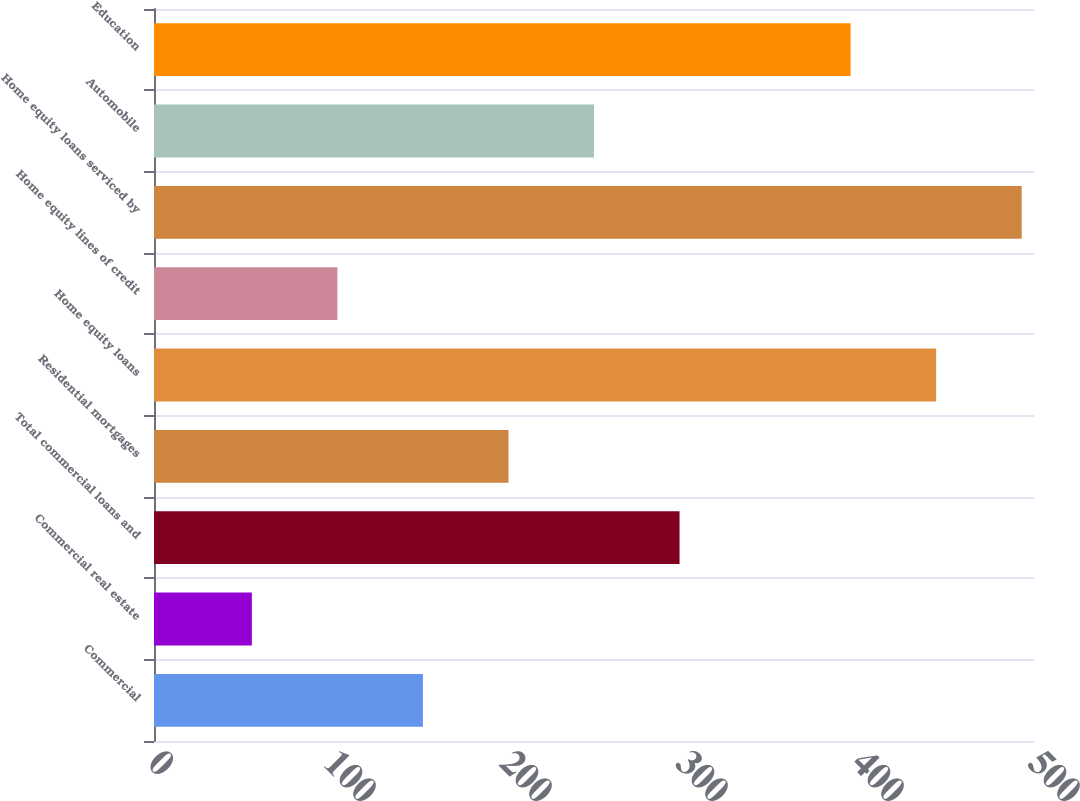<chart> <loc_0><loc_0><loc_500><loc_500><bar_chart><fcel>Commercial<fcel>Commercial real estate<fcel>Total commercial loans and<fcel>Residential mortgages<fcel>Home equity loans<fcel>Home equity lines of credit<fcel>Home equity loans serviced by<fcel>Automobile<fcel>Education<nl><fcel>152.8<fcel>55.6<fcel>298.6<fcel>201.4<fcel>444.4<fcel>104.2<fcel>493<fcel>250<fcel>395.8<nl></chart> 